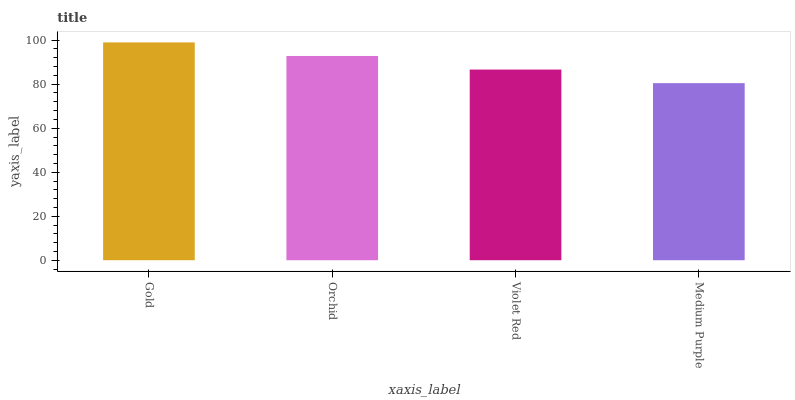Is Medium Purple the minimum?
Answer yes or no. Yes. Is Gold the maximum?
Answer yes or no. Yes. Is Orchid the minimum?
Answer yes or no. No. Is Orchid the maximum?
Answer yes or no. No. Is Gold greater than Orchid?
Answer yes or no. Yes. Is Orchid less than Gold?
Answer yes or no. Yes. Is Orchid greater than Gold?
Answer yes or no. No. Is Gold less than Orchid?
Answer yes or no. No. Is Orchid the high median?
Answer yes or no. Yes. Is Violet Red the low median?
Answer yes or no. Yes. Is Gold the high median?
Answer yes or no. No. Is Gold the low median?
Answer yes or no. No. 